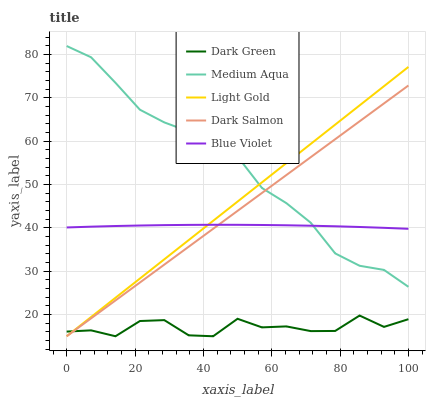Does Dark Green have the minimum area under the curve?
Answer yes or no. Yes. Does Medium Aqua have the maximum area under the curve?
Answer yes or no. Yes. Does Dark Salmon have the minimum area under the curve?
Answer yes or no. No. Does Dark Salmon have the maximum area under the curve?
Answer yes or no. No. Is Dark Salmon the smoothest?
Answer yes or no. Yes. Is Dark Green the roughest?
Answer yes or no. Yes. Is Medium Aqua the smoothest?
Answer yes or no. No. Is Medium Aqua the roughest?
Answer yes or no. No. Does Light Gold have the lowest value?
Answer yes or no. Yes. Does Medium Aqua have the lowest value?
Answer yes or no. No. Does Medium Aqua have the highest value?
Answer yes or no. Yes. Does Dark Salmon have the highest value?
Answer yes or no. No. Is Dark Green less than Blue Violet?
Answer yes or no. Yes. Is Medium Aqua greater than Dark Green?
Answer yes or no. Yes. Does Light Gold intersect Dark Green?
Answer yes or no. Yes. Is Light Gold less than Dark Green?
Answer yes or no. No. Is Light Gold greater than Dark Green?
Answer yes or no. No. Does Dark Green intersect Blue Violet?
Answer yes or no. No. 